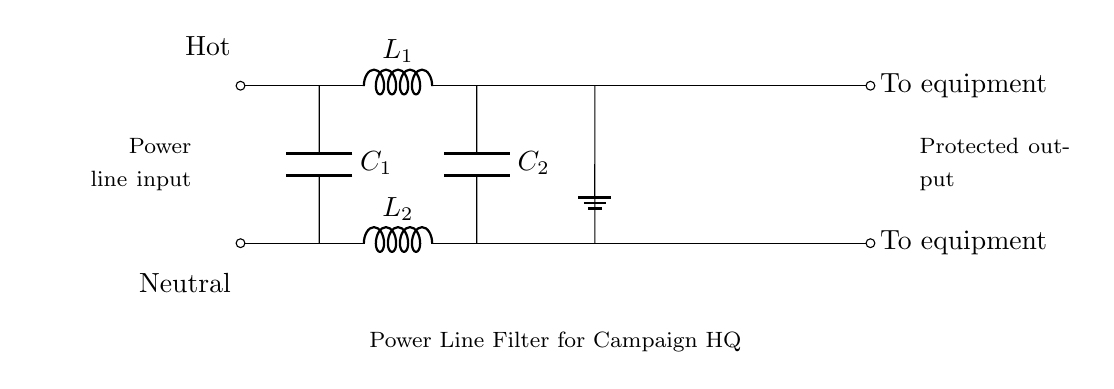What types of components are present in this circuit? The circuit contains inductors and capacitors, specifically labeled as L1, L2, C1, and C2. These components are essential for filtering unwanted noise.
Answer: Inductors and capacitors What is the function of the inductors in this circuit? The inductors L1 and L2 serve to impede the flow of high-frequency noise and voltage spikes, effectively filtering the power line and protecting equipment.
Answer: Filter high-frequency noise How many capacitors are present in the circuit? There are two capacitors identified as C1 and C2, which are positioned in parallel with the inductors to aid in filtering and stabilization.
Answer: Two What do the labels "Hot" and "Neutral" signify in this circuit? The label "Hot" indicates the live wire that carries current, while "Neutral" refers to the return path for current. This setup is crucial for understanding the power flow.
Answer: Live and return paths Which output serves as the protected output in this circuit? The output labeled "To equipment" at the far right side of the circuit diagram delivers the filtered power to the sensitive electronic devices, which is the desired outcome of the filtering process.
Answer: To equipment How does this circuit represent a power line filter? The combination of inductors and capacitors arranged in this manner creates a filter that suppresses frequencies outside the desired range, allowing only stable power to pass through to the equipment.
Answer: Inductor-capacitor arrangement What is the purpose of grounding in this circuit? The ground connection provides a reference point for voltage and helps ensure safety by redirecting excess current away from the equipment in case of a fault.
Answer: Safety and reference voltage 